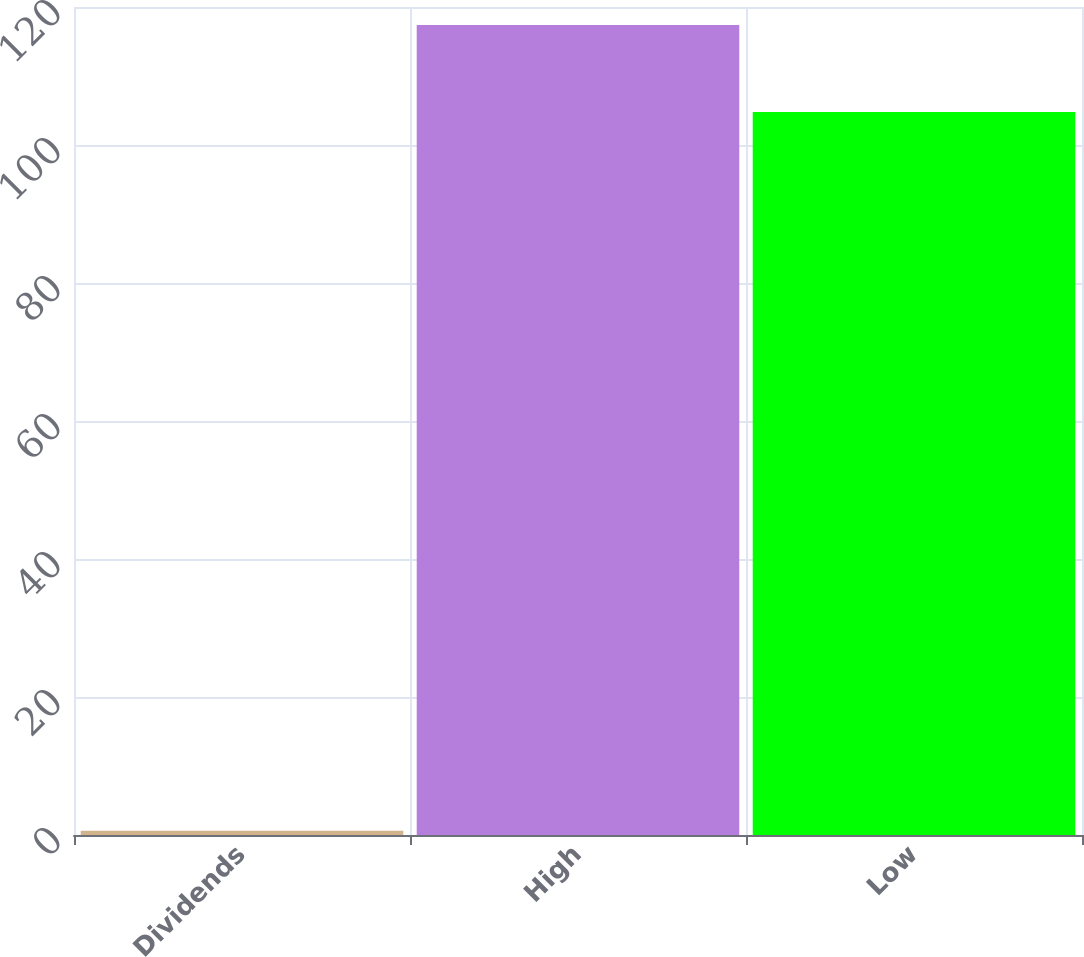<chart> <loc_0><loc_0><loc_500><loc_500><bar_chart><fcel>Dividends<fcel>High<fcel>Low<nl><fcel>0.6<fcel>117.4<fcel>104.77<nl></chart> 